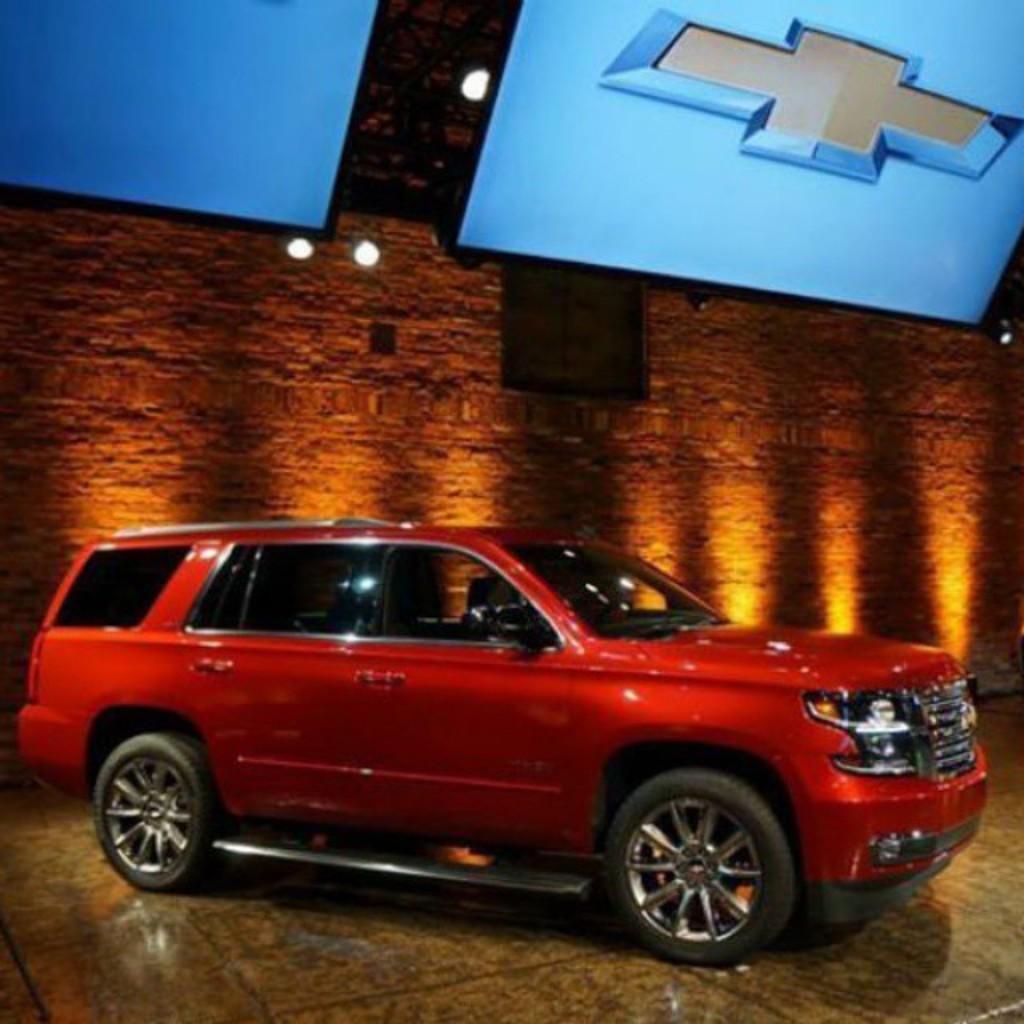Describe this image in one or two sentences. In this image in the center there is one car and in the background there is a wall, at the bottom there is a floor and on the top there are two televisions. 